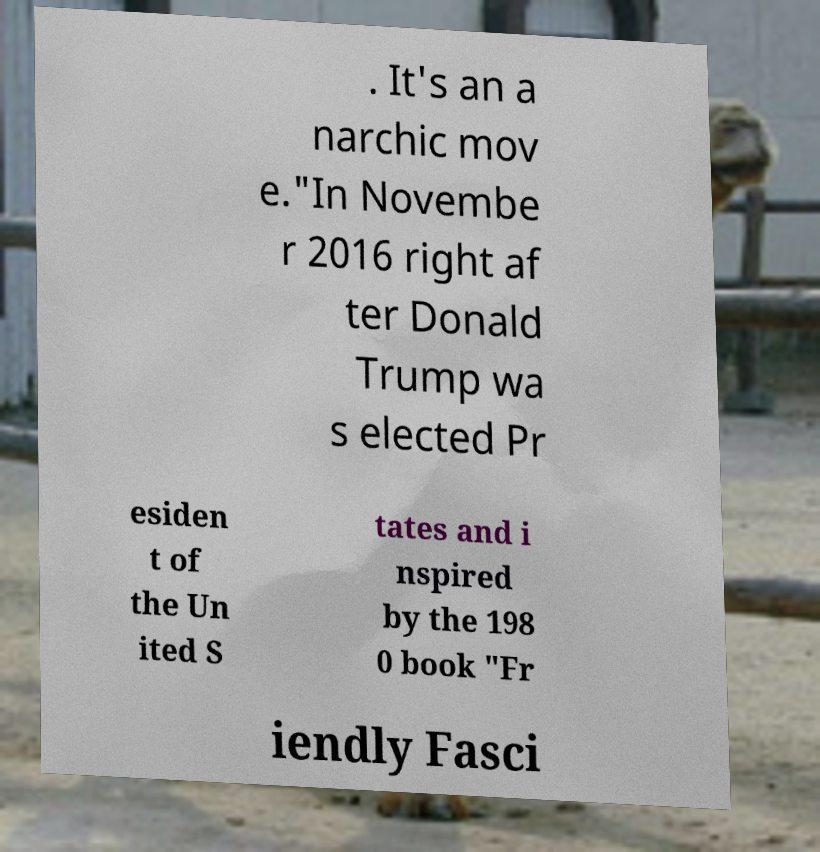Please read and relay the text visible in this image. What does it say? . It's an a narchic mov e."In Novembe r 2016 right af ter Donald Trump wa s elected Pr esiden t of the Un ited S tates and i nspired by the 198 0 book "Fr iendly Fasci 